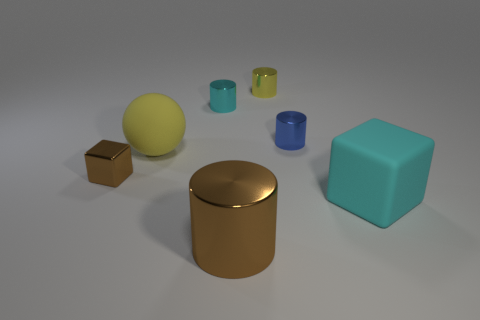Add 2 small yellow metallic objects. How many objects exist? 9 Subtract all yellow metallic cylinders. How many cylinders are left? 3 Subtract all balls. How many objects are left? 6 Add 7 big yellow rubber spheres. How many big yellow rubber spheres are left? 8 Add 5 tiny metal spheres. How many tiny metal spheres exist? 5 Subtract all blue cylinders. How many cylinders are left? 3 Subtract 0 green cylinders. How many objects are left? 7 Subtract all red blocks. Subtract all brown spheres. How many blocks are left? 2 Subtract all yellow metal cylinders. Subtract all yellow matte things. How many objects are left? 5 